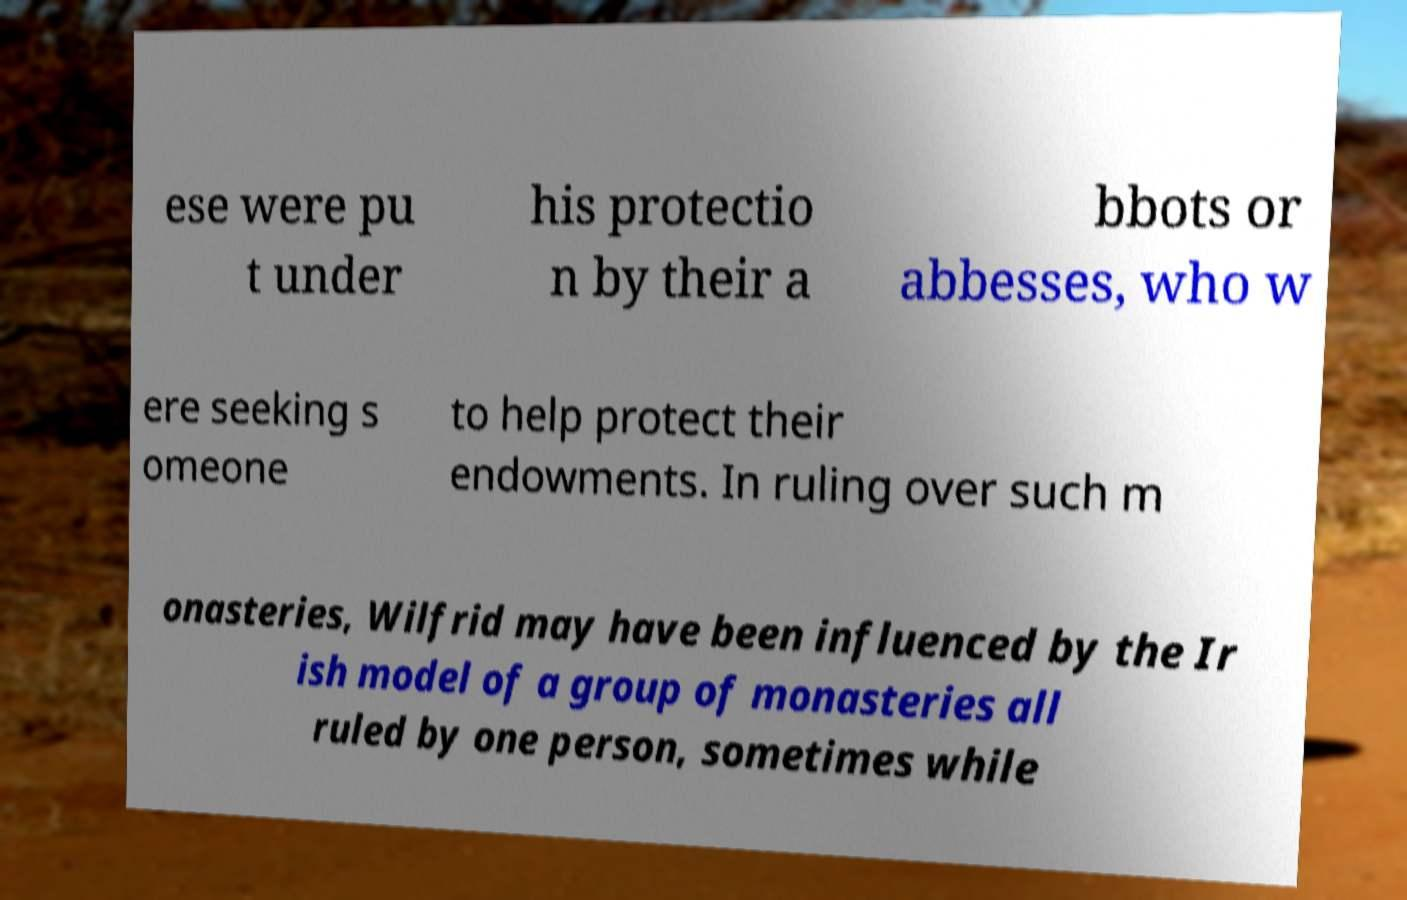Could you extract and type out the text from this image? ese were pu t under his protectio n by their a bbots or abbesses, who w ere seeking s omeone to help protect their endowments. In ruling over such m onasteries, Wilfrid may have been influenced by the Ir ish model of a group of monasteries all ruled by one person, sometimes while 